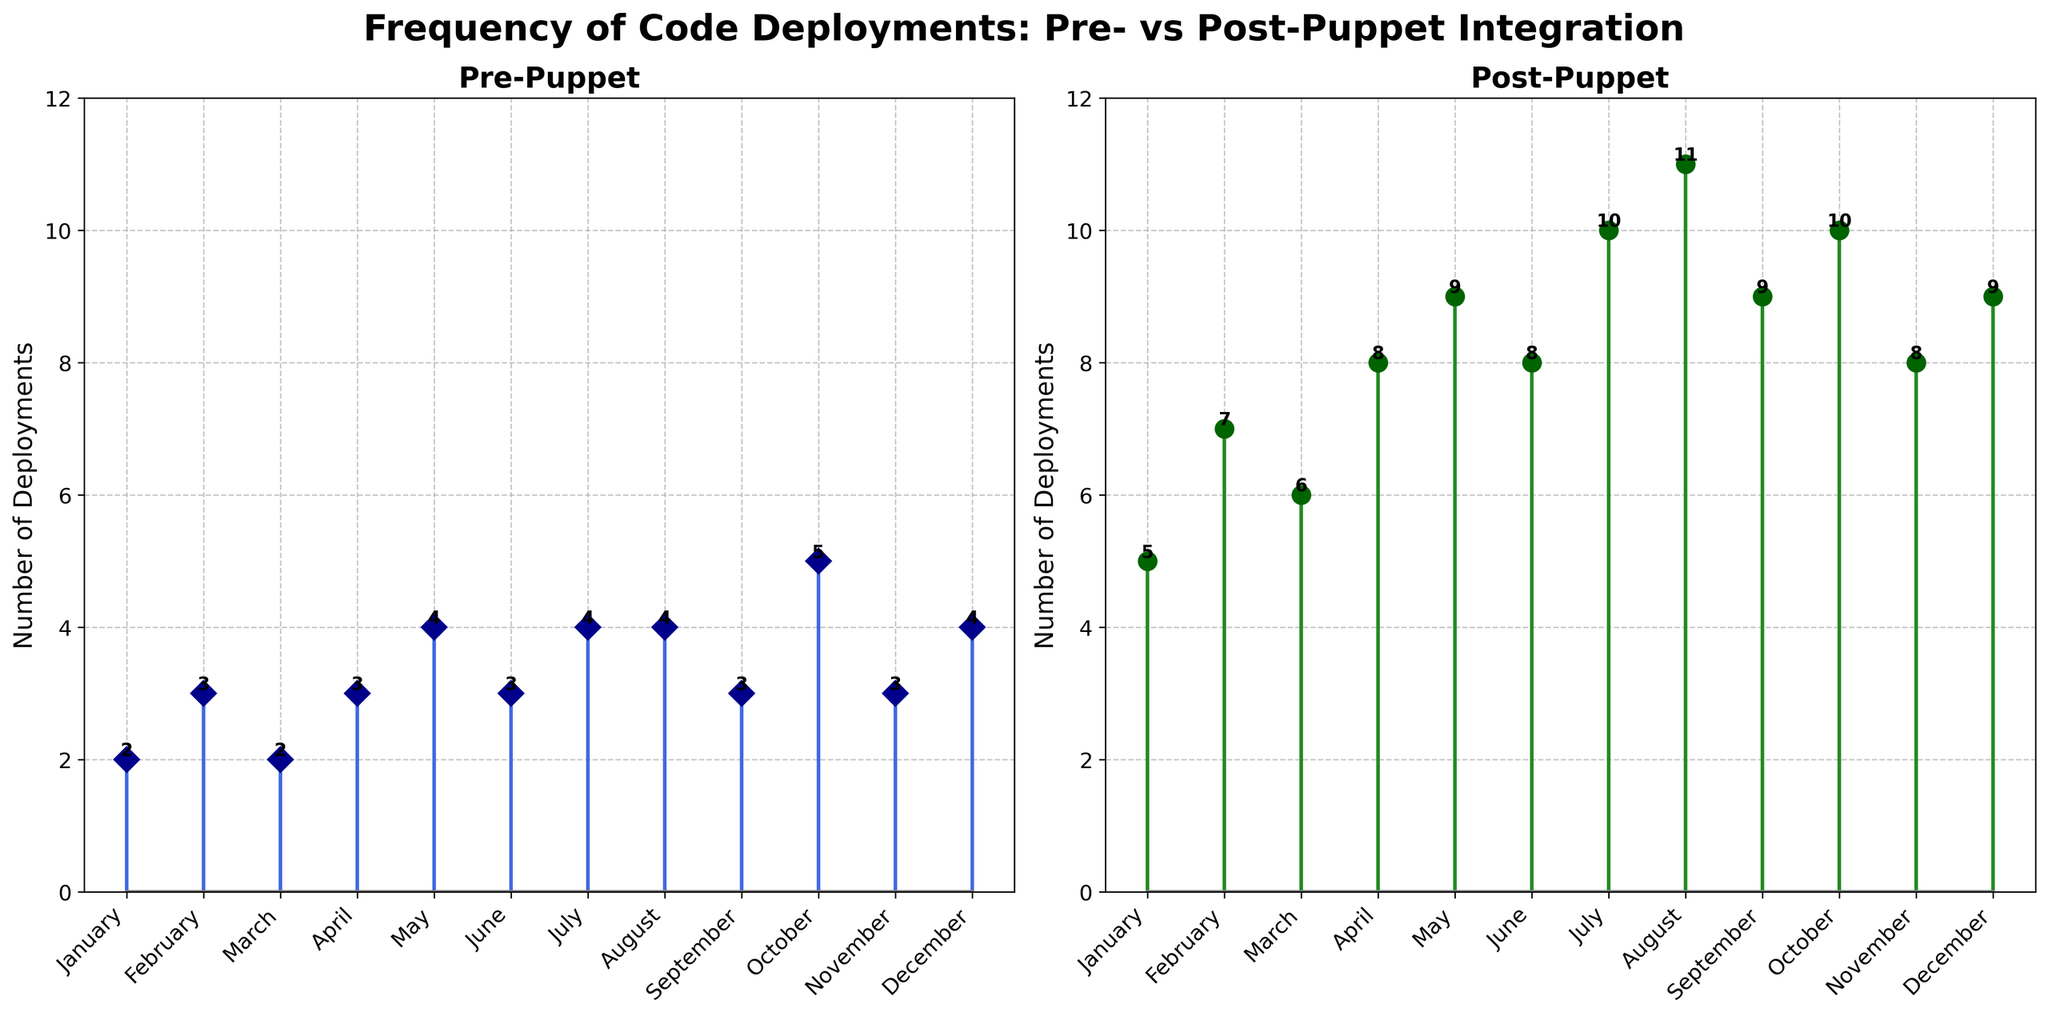What is the title of the figure? The title of the figure is given at the top of the plot. It reads "Frequency of Code Deployments: Pre- vs Post-Puppet Integration".
Answer: Frequency of Code Deployments: Pre- vs Post-Puppet Integration How many months are displayed in the figure? The x-axis shows labels for each month from January to December. Counting these labels gives a total of 12 months.
Answer: 12 What color is used for the Post-Puppet deployments? The Post-Puppet deployment data points are indicated by green markers and lines in the figure. Specifically, dark green for markers and forest green for lines.
Answer: Green How many deployments were there in February before Puppet was integrated? By looking at the stem plot labeled 'Pre-Puppet' and finding February on the x-axis, we see that the stem reaches up to 3.
Answer: 3 What is the average number of code deployments in the Post-Puppet phase? To find the average, sum the number of deployments for each month after Puppet integration (5 + 7 + 6 + 8 + 9 + 8 + 10 + 11 + 9 + 10 + 8 + 9) which equals 100, and then divide by the number of months (12): 100 / 12.
Answer: 8.33 What is the difference in the number of code deployments between March and July for the Pre-Puppet integration? From the 'Pre-Puppet' subplot, March shows 2 deployments and July shows 4. The difference is calculated as 4 - 2.
Answer: 2 Which month shows the highest increase in deployments from Pre-Puppet to Post-Puppet? By comparing the values month by month, August shows the highest increase. Pre-Puppet is 4 and Post-Puppet is 11. The increase is 11 - 4.
Answer: August In how many months did the number of deployments remain identical between Pre-Puppet and Post-Puppet? By comparing the data for each month, none of the months show identical deployment numbers between Pre-Puppet and Post-Puppet integration.
Answer: 0 In which month are the deployments the same for Pre-Puppet and Post-Puppet? The stem plots can be checked to see if there's a month where the stems align vertically. There is no month where the number of deployments is identical in both plots.
Answer: None How many months have a higher number of deployments after integrating Puppet? By comparing each month's values on the plots, all 12 months show higher deployments after integrating Puppet.
Answer: 12 